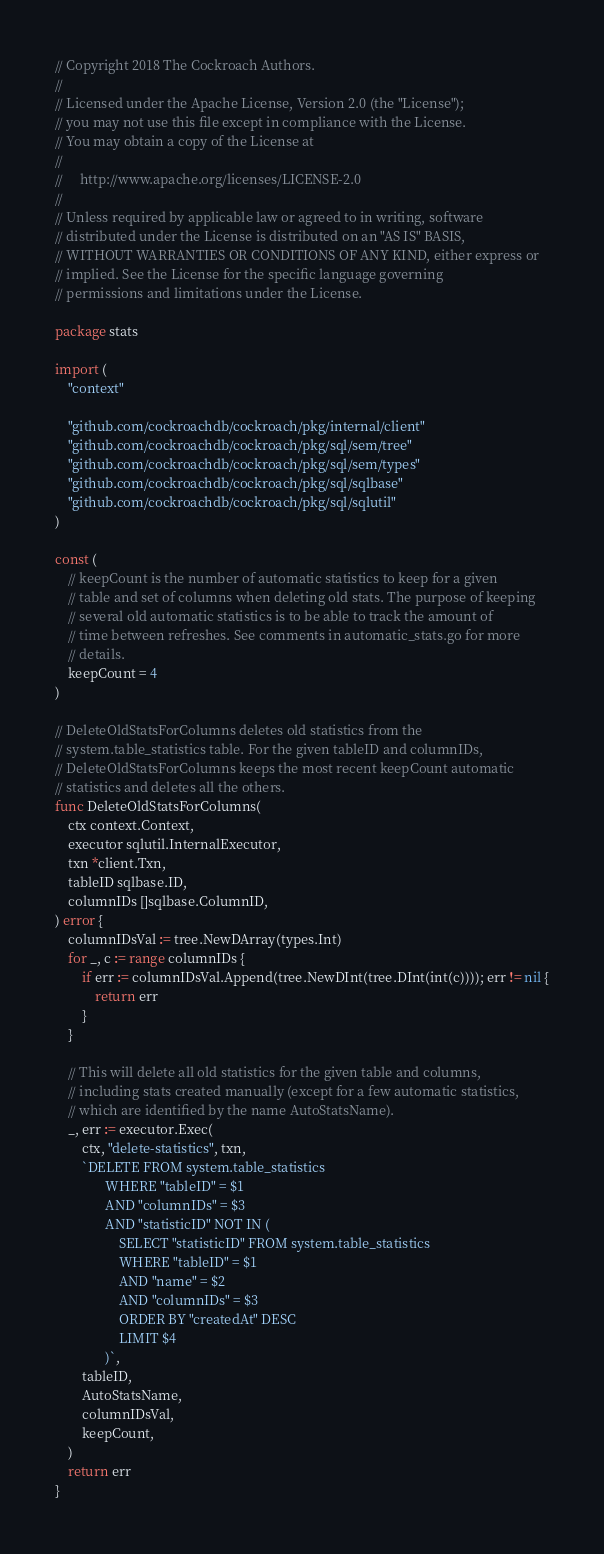<code> <loc_0><loc_0><loc_500><loc_500><_Go_>// Copyright 2018 The Cockroach Authors.
//
// Licensed under the Apache License, Version 2.0 (the "License");
// you may not use this file except in compliance with the License.
// You may obtain a copy of the License at
//
//     http://www.apache.org/licenses/LICENSE-2.0
//
// Unless required by applicable law or agreed to in writing, software
// distributed under the License is distributed on an "AS IS" BASIS,
// WITHOUT WARRANTIES OR CONDITIONS OF ANY KIND, either express or
// implied. See the License for the specific language governing
// permissions and limitations under the License.

package stats

import (
	"context"

	"github.com/cockroachdb/cockroach/pkg/internal/client"
	"github.com/cockroachdb/cockroach/pkg/sql/sem/tree"
	"github.com/cockroachdb/cockroach/pkg/sql/sem/types"
	"github.com/cockroachdb/cockroach/pkg/sql/sqlbase"
	"github.com/cockroachdb/cockroach/pkg/sql/sqlutil"
)

const (
	// keepCount is the number of automatic statistics to keep for a given
	// table and set of columns when deleting old stats. The purpose of keeping
	// several old automatic statistics is to be able to track the amount of
	// time between refreshes. See comments in automatic_stats.go for more
	// details.
	keepCount = 4
)

// DeleteOldStatsForColumns deletes old statistics from the
// system.table_statistics table. For the given tableID and columnIDs,
// DeleteOldStatsForColumns keeps the most recent keepCount automatic
// statistics and deletes all the others.
func DeleteOldStatsForColumns(
	ctx context.Context,
	executor sqlutil.InternalExecutor,
	txn *client.Txn,
	tableID sqlbase.ID,
	columnIDs []sqlbase.ColumnID,
) error {
	columnIDsVal := tree.NewDArray(types.Int)
	for _, c := range columnIDs {
		if err := columnIDsVal.Append(tree.NewDInt(tree.DInt(int(c)))); err != nil {
			return err
		}
	}

	// This will delete all old statistics for the given table and columns,
	// including stats created manually (except for a few automatic statistics,
	// which are identified by the name AutoStatsName).
	_, err := executor.Exec(
		ctx, "delete-statistics", txn,
		`DELETE FROM system.table_statistics
               WHERE "tableID" = $1
               AND "columnIDs" = $3
               AND "statisticID" NOT IN (
                   SELECT "statisticID" FROM system.table_statistics
                   WHERE "tableID" = $1
                   AND "name" = $2
                   AND "columnIDs" = $3
                   ORDER BY "createdAt" DESC
                   LIMIT $4
               )`,
		tableID,
		AutoStatsName,
		columnIDsVal,
		keepCount,
	)
	return err
}
</code> 